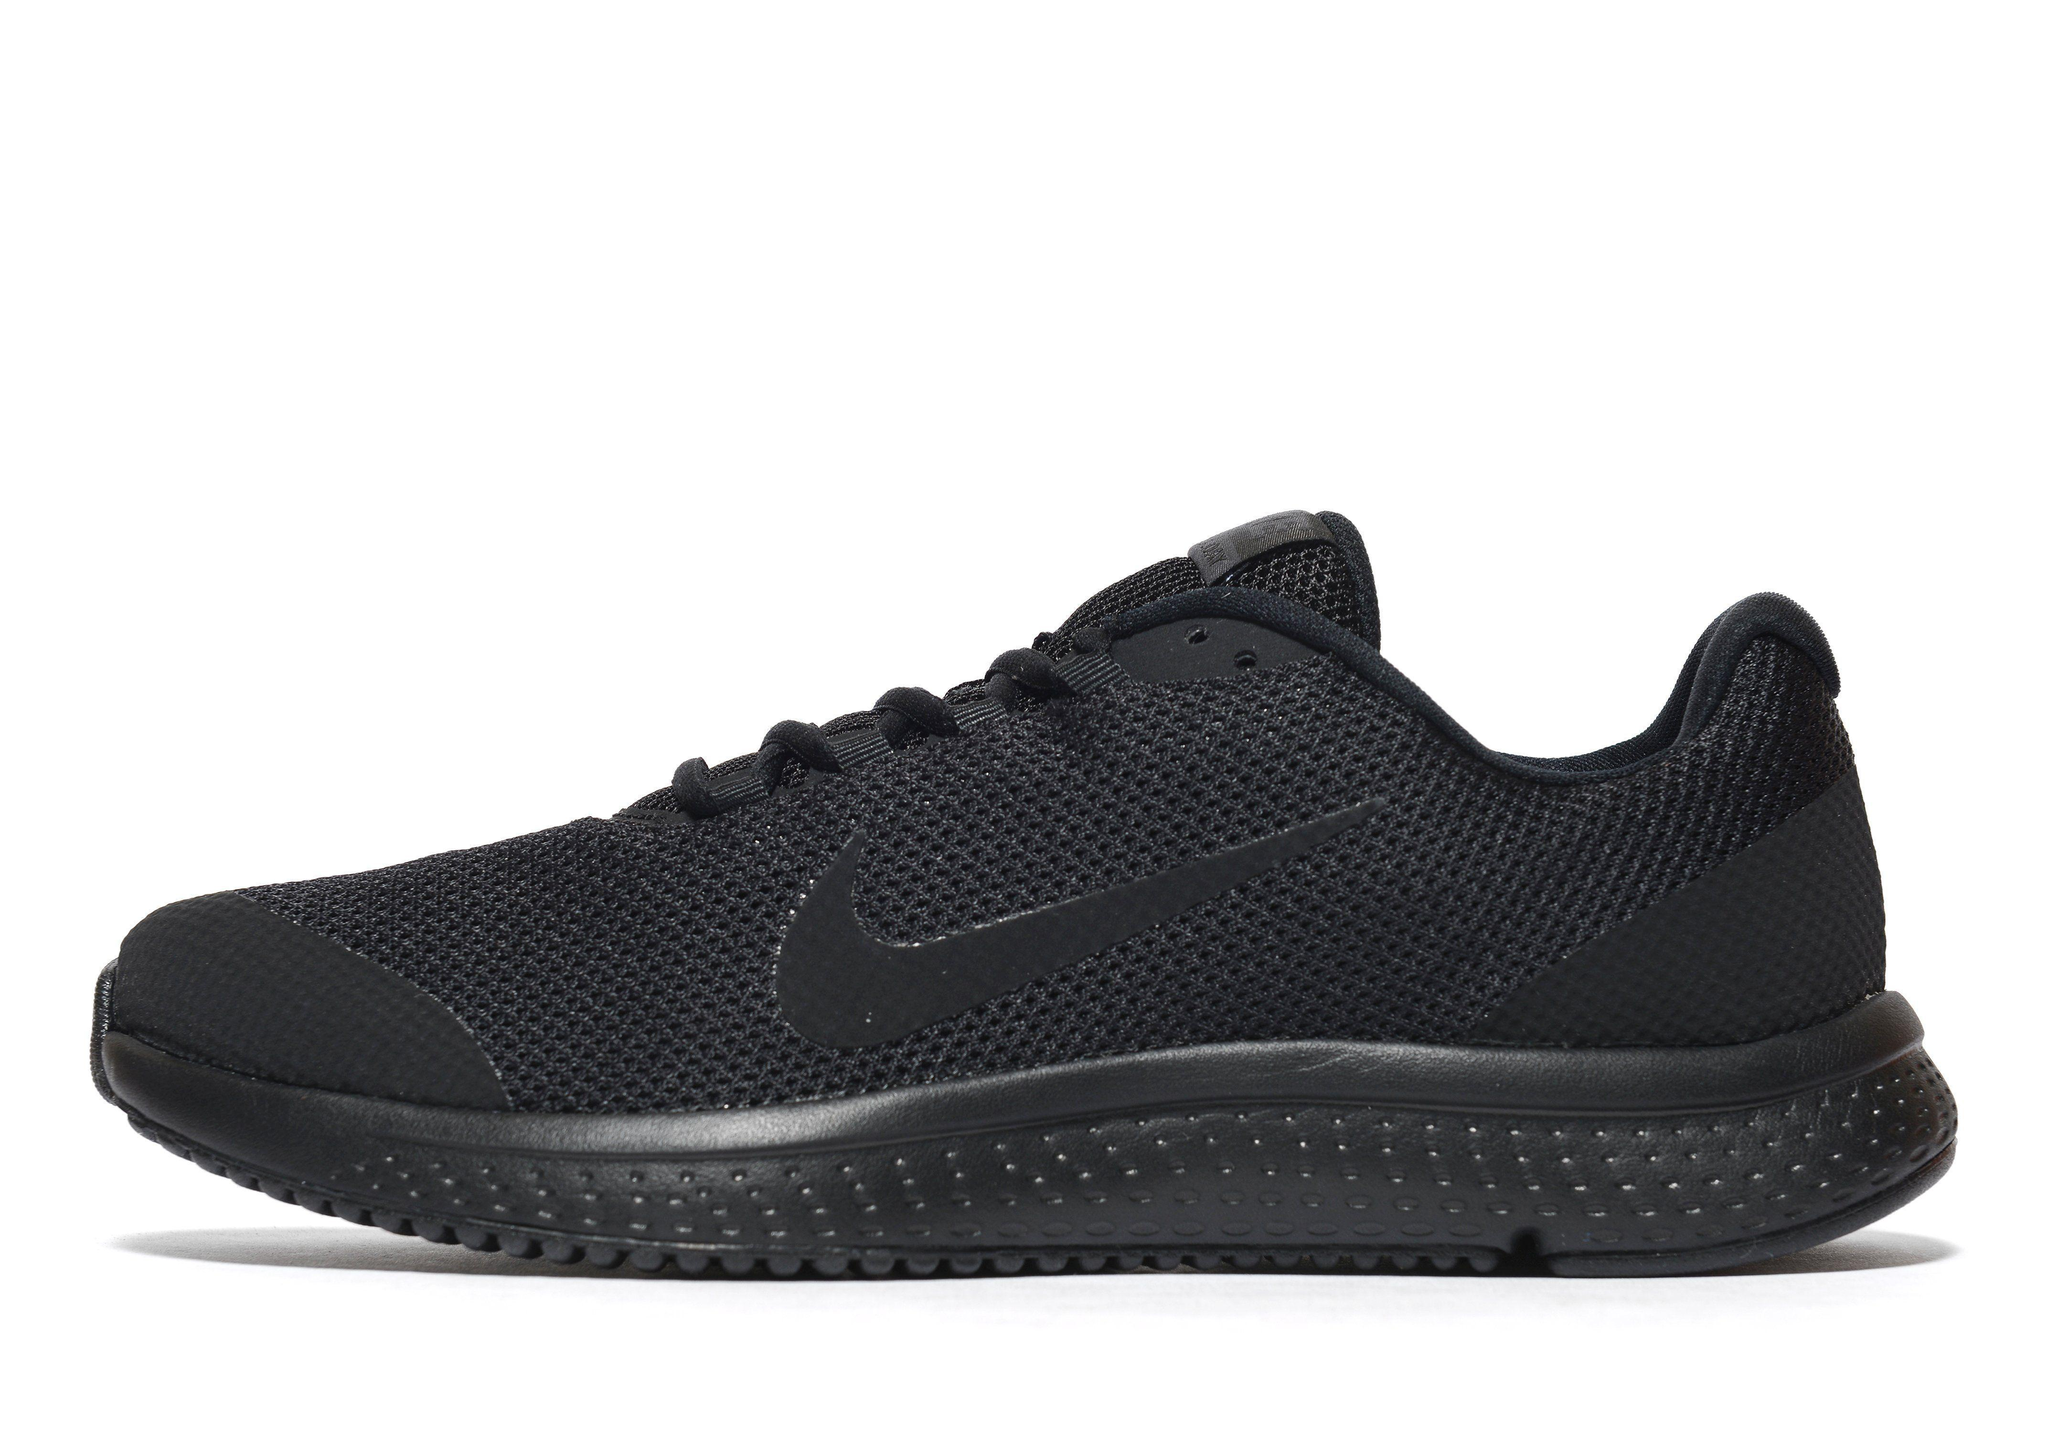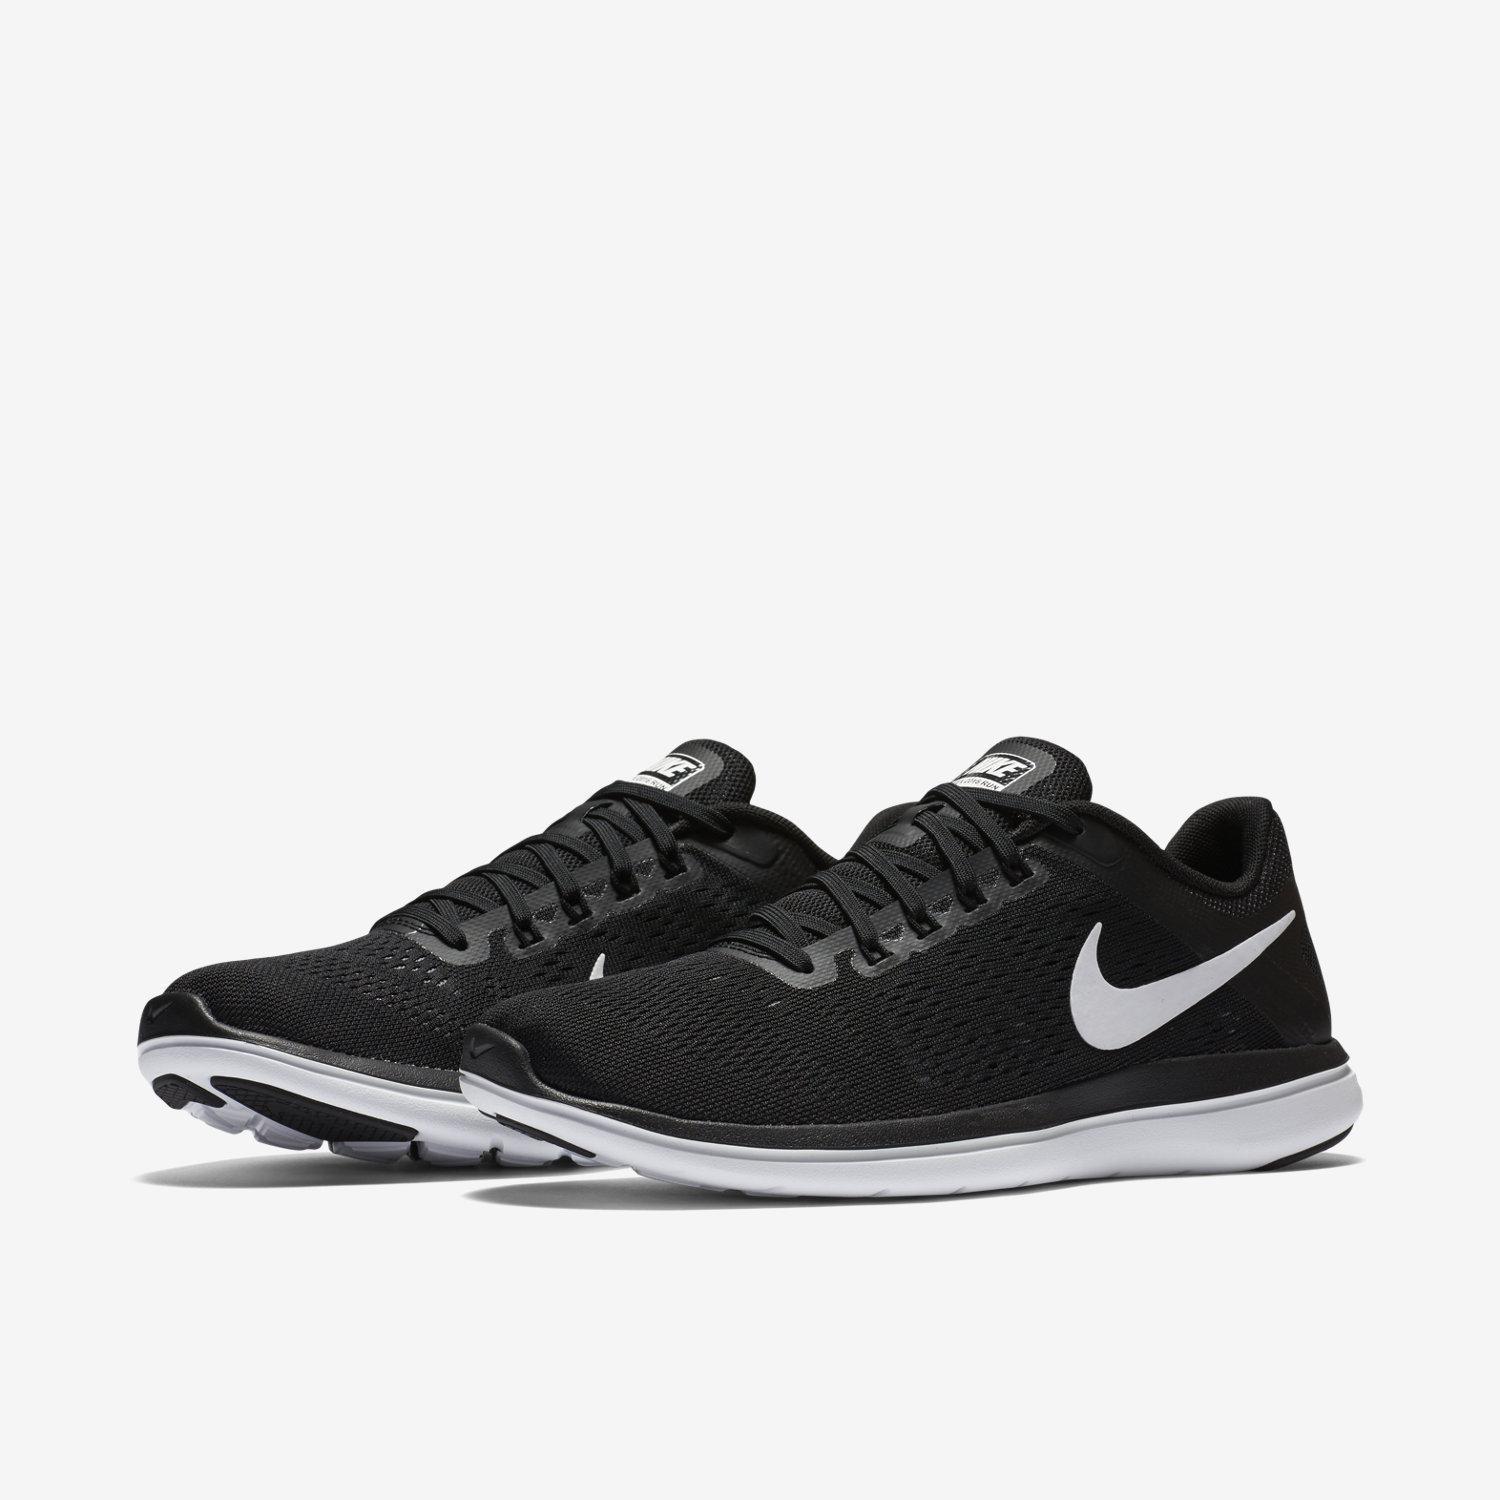The first image is the image on the left, the second image is the image on the right. For the images displayed, is the sentence "Three shoe color options are shown in one image." factually correct? Answer yes or no. No. 